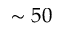Convert formula to latex. <formula><loc_0><loc_0><loc_500><loc_500>\sim 5 0</formula> 